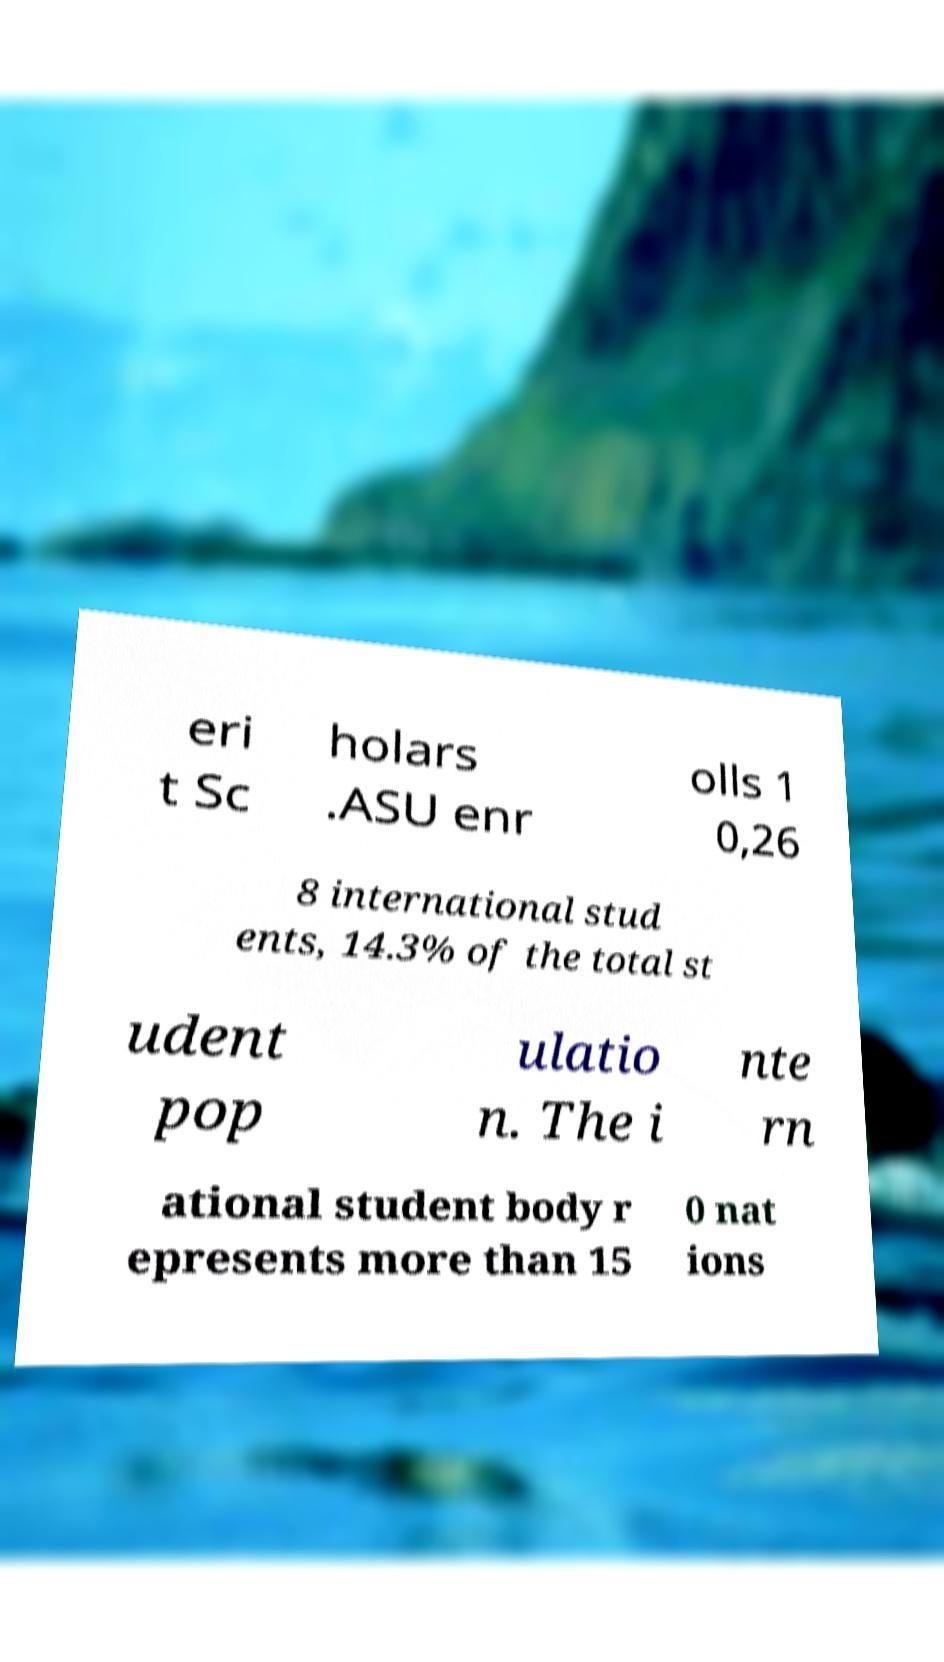What messages or text are displayed in this image? I need them in a readable, typed format. eri t Sc holars .ASU enr olls 1 0,26 8 international stud ents, 14.3% of the total st udent pop ulatio n. The i nte rn ational student body r epresents more than 15 0 nat ions 